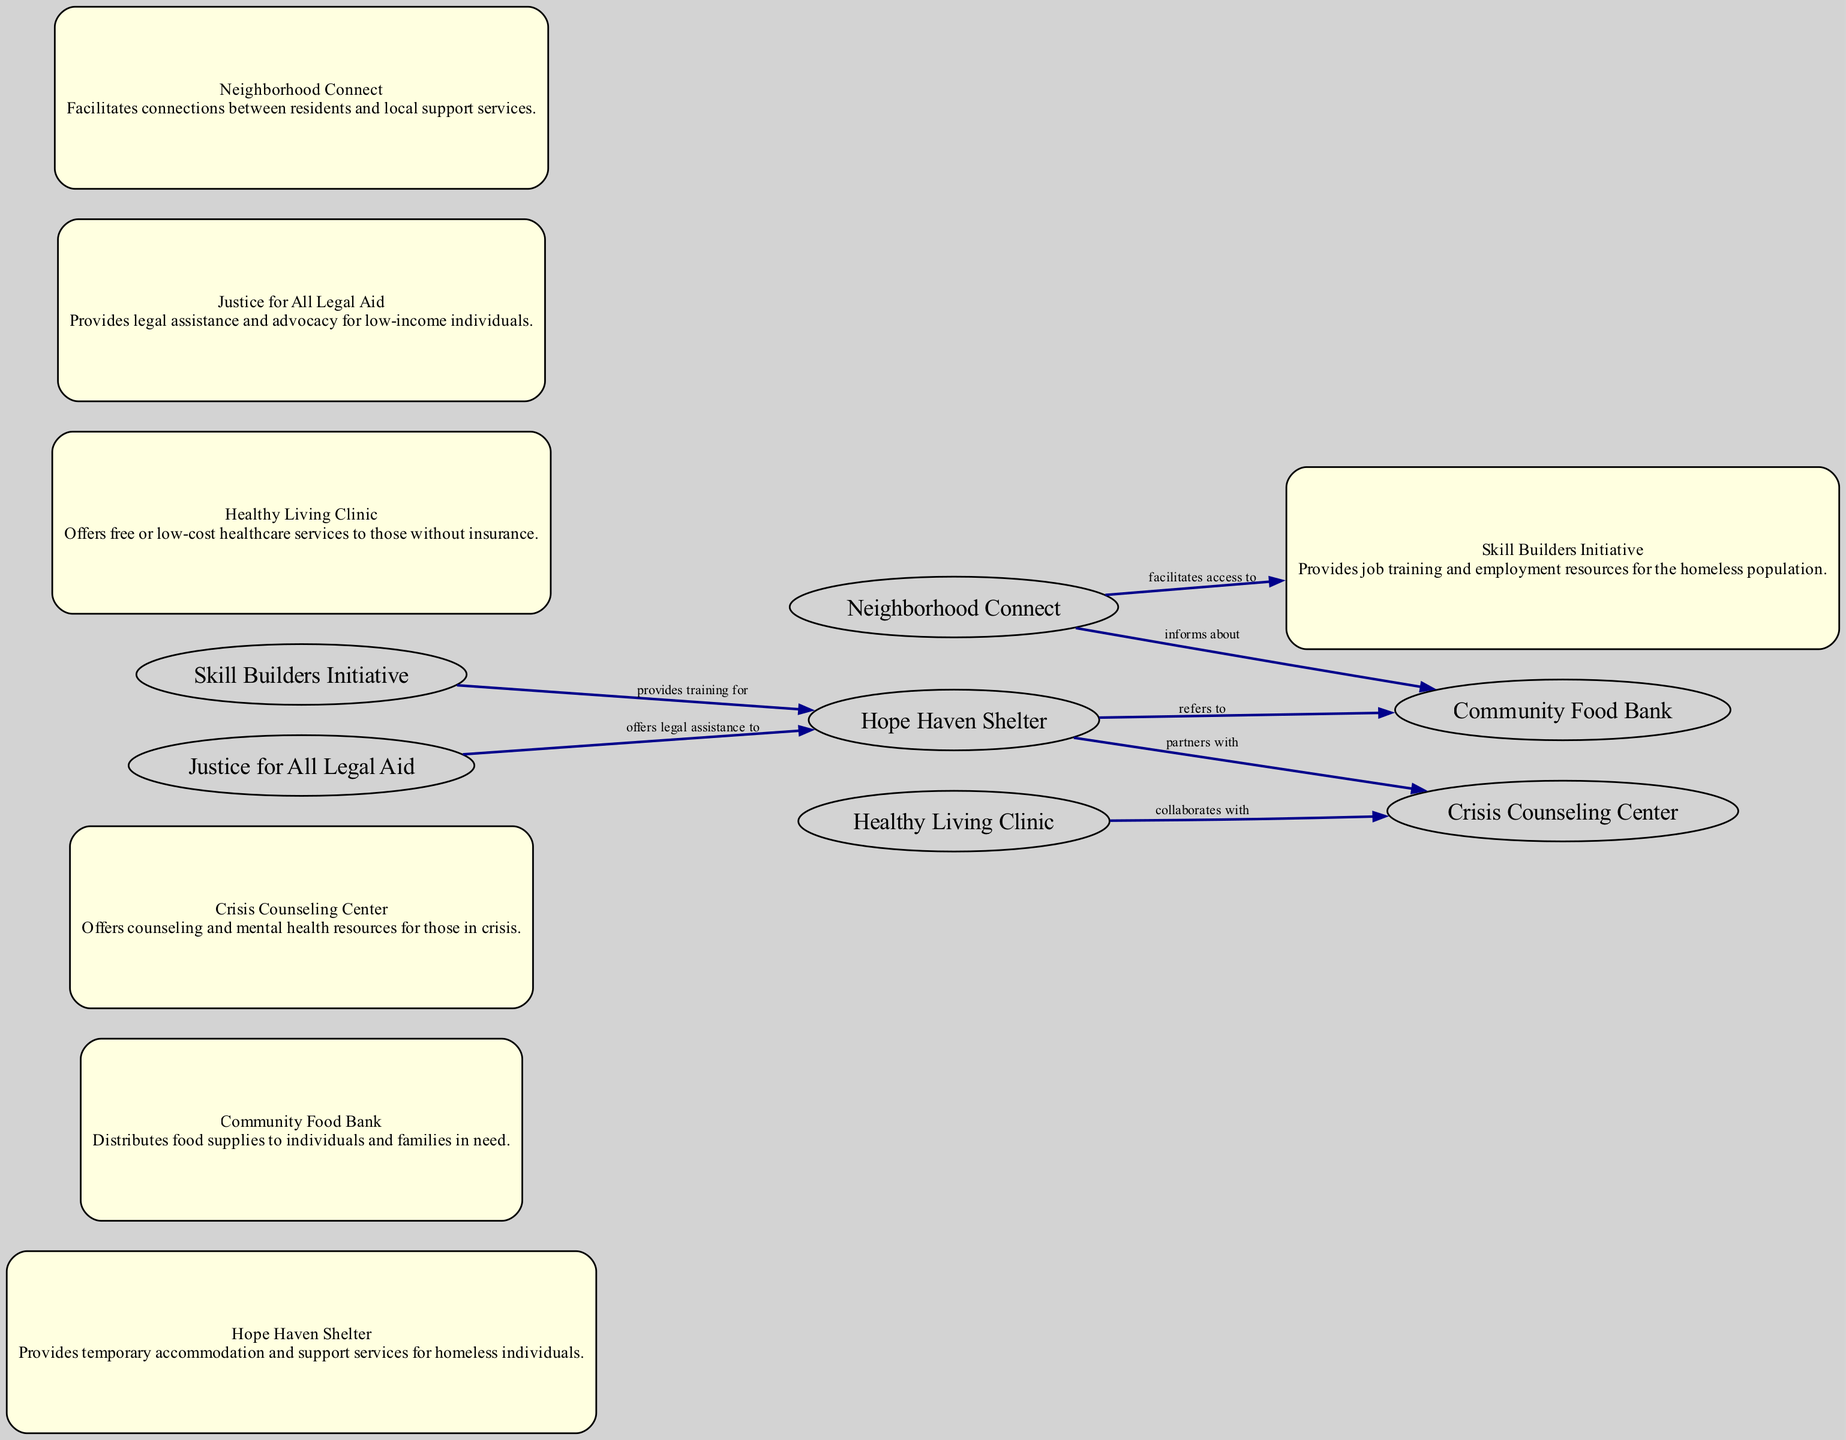What is the total number of nodes in the diagram? To find the total number of nodes, we can count the distinct entities listed in the data set under the "nodes" section. There are 7 nodes present: Hope Haven Shelter, Community Food Bank, Crisis Counseling Center, Skill Builders Initiative, Healthy Living Clinic, Justice for All Legal Aid, and Neighborhood Connect.
Answer: 7 Which service does the Hope Haven Shelter refer to? The diagram indicates that the Hope Haven Shelter has a directed edge pointing to the Community Food Bank with the label "refers to." This indicates the specific service that this shelter directs individuals to for food assistance.
Answer: Community Food Bank How many edges are represented in the diagram? We can determine the number of edges by counting the connections between nodes that are listed in the "edges" section. There are 6 edges specified, representing different relationships among the nodes.
Answer: 6 Which organization collaborates with the Healthy Living Clinic? By examining the edges, we can see that there is a directed connection from the Healthy Living Clinic to the Crisis Counseling Center labeled "collaborates with." This indicates that the Healthy Living Clinic partners with this service.
Answer: Crisis Counseling Center What type of support does the Skill Builders Initiative provide? The diagram shows a connection from the Skill Builders Initiative to the Hope Haven Shelter with the label "provides training for." This indicates that the type of support provided is related to job training and preparation for those in the shelter.
Answer: training Which organization informs about the Community Food Bank? The Neighborhood Connect has a directed edge pointing to the Community Food Bank with the label "informs about." This indicates that the Neighborhood Connect organization plays a role in disseminating information regarding the food bank services.
Answer: Neighborhood Connect What is the relationship between the Crisis Counseling Center and the Hope Haven Shelter? The diagram indicates a partnership between these two services, as shown by the directed edge from the Hope Haven Shelter to the Crisis Counseling Center with the label "partners with." This shows a collaborative relationship between them.
Answer: partners with Which organization provides legal assistance to individuals in the Hope Haven Shelter? The directed edge from Justice for All Legal Aid to Hope Haven Shelter indicates that this legal aid organization offers assistance specifically to those residing in the shelter.
Answer: Justice for All Legal Aid 